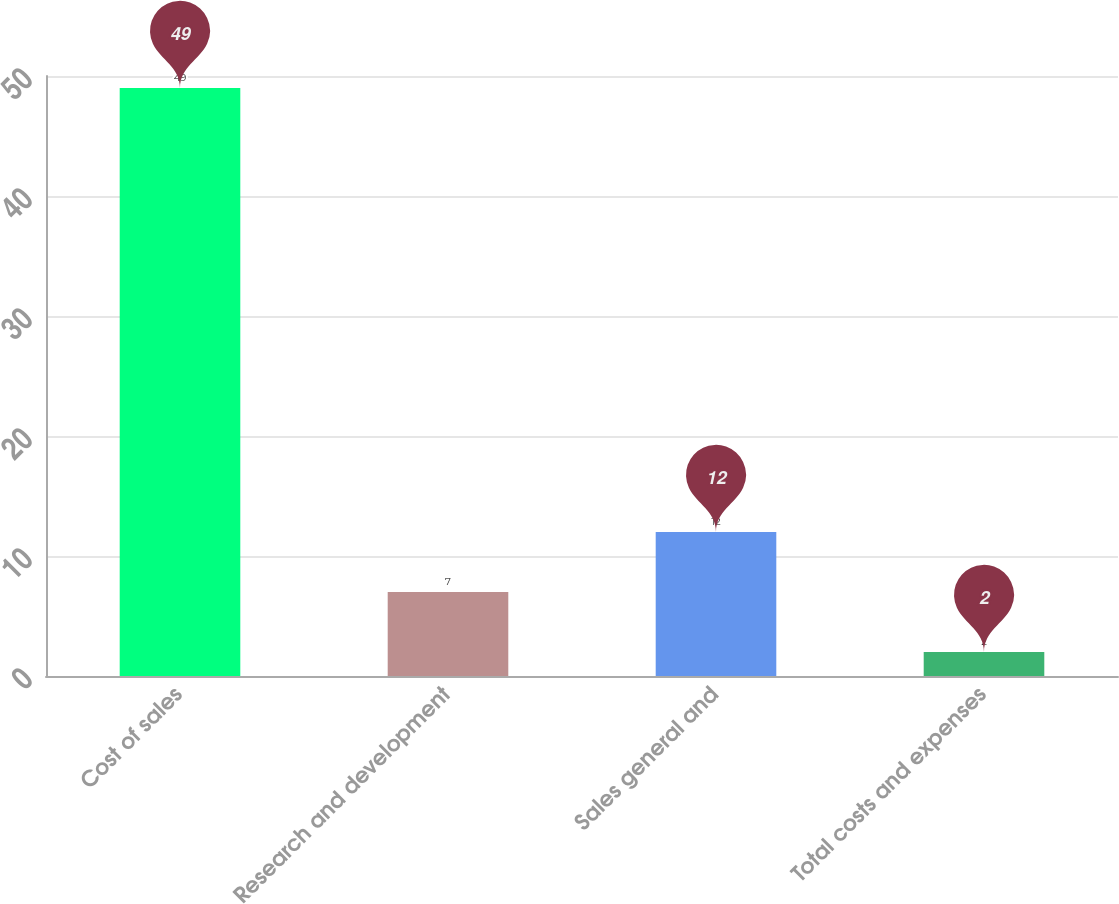<chart> <loc_0><loc_0><loc_500><loc_500><bar_chart><fcel>Cost of sales<fcel>Research and development<fcel>Sales general and<fcel>Total costs and expenses<nl><fcel>49<fcel>7<fcel>12<fcel>2<nl></chart> 